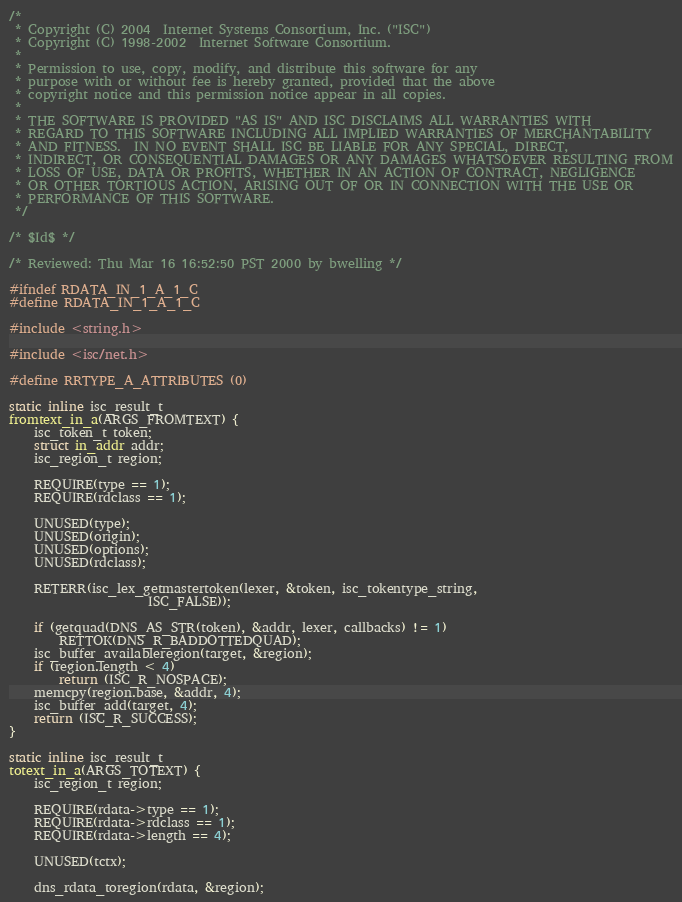Convert code to text. <code><loc_0><loc_0><loc_500><loc_500><_C_>/*
 * Copyright (C) 2004  Internet Systems Consortium, Inc. ("ISC")
 * Copyright (C) 1998-2002  Internet Software Consortium.
 *
 * Permission to use, copy, modify, and distribute this software for any
 * purpose with or without fee is hereby granted, provided that the above
 * copyright notice and this permission notice appear in all copies.
 *
 * THE SOFTWARE IS PROVIDED "AS IS" AND ISC DISCLAIMS ALL WARRANTIES WITH
 * REGARD TO THIS SOFTWARE INCLUDING ALL IMPLIED WARRANTIES OF MERCHANTABILITY
 * AND FITNESS.  IN NO EVENT SHALL ISC BE LIABLE FOR ANY SPECIAL, DIRECT,
 * INDIRECT, OR CONSEQUENTIAL DAMAGES OR ANY DAMAGES WHATSOEVER RESULTING FROM
 * LOSS OF USE, DATA OR PROFITS, WHETHER IN AN ACTION OF CONTRACT, NEGLIGENCE
 * OR OTHER TORTIOUS ACTION, ARISING OUT OF OR IN CONNECTION WITH THE USE OR
 * PERFORMANCE OF THIS SOFTWARE.
 */

/* $Id$ */

/* Reviewed: Thu Mar 16 16:52:50 PST 2000 by bwelling */

#ifndef RDATA_IN_1_A_1_C
#define RDATA_IN_1_A_1_C

#include <string.h>

#include <isc/net.h>

#define RRTYPE_A_ATTRIBUTES (0)

static inline isc_result_t
fromtext_in_a(ARGS_FROMTEXT) {
	isc_token_t token;
	struct in_addr addr;
	isc_region_t region;

	REQUIRE(type == 1);
	REQUIRE(rdclass == 1);

	UNUSED(type);
	UNUSED(origin);
	UNUSED(options);
	UNUSED(rdclass);

	RETERR(isc_lex_getmastertoken(lexer, &token, isc_tokentype_string,
				      ISC_FALSE));

	if (getquad(DNS_AS_STR(token), &addr, lexer, callbacks) != 1)
		RETTOK(DNS_R_BADDOTTEDQUAD);
	isc_buffer_availableregion(target, &region);
	if (region.length < 4)
		return (ISC_R_NOSPACE);
	memcpy(region.base, &addr, 4);
	isc_buffer_add(target, 4);
	return (ISC_R_SUCCESS);
}

static inline isc_result_t
totext_in_a(ARGS_TOTEXT) {
	isc_region_t region;

	REQUIRE(rdata->type == 1);
	REQUIRE(rdata->rdclass == 1);
	REQUIRE(rdata->length == 4);

	UNUSED(tctx);

	dns_rdata_toregion(rdata, &region);</code> 